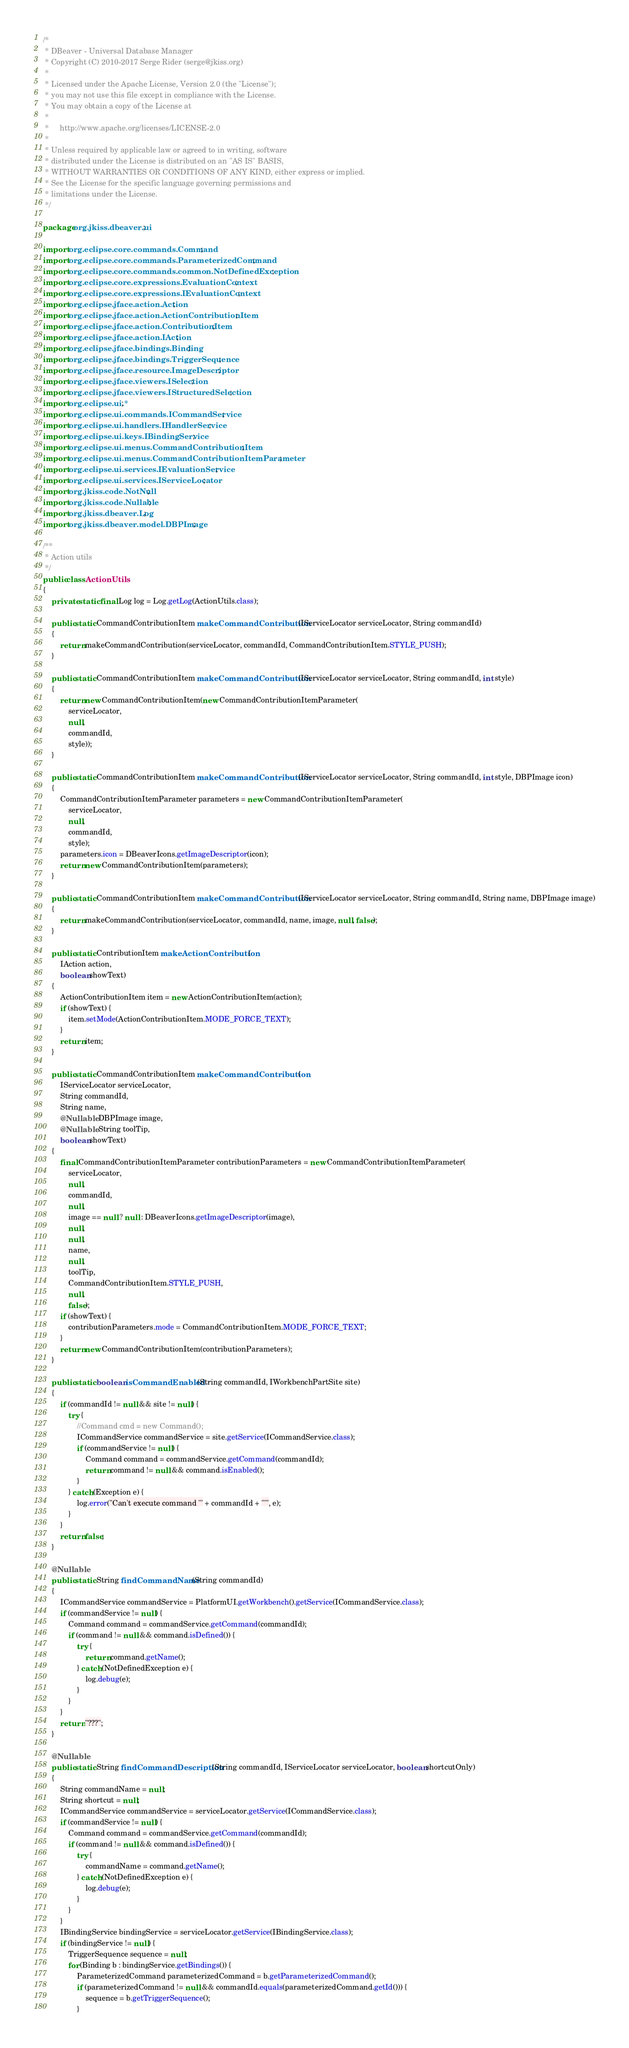<code> <loc_0><loc_0><loc_500><loc_500><_Java_>/*
 * DBeaver - Universal Database Manager
 * Copyright (C) 2010-2017 Serge Rider (serge@jkiss.org)
 *
 * Licensed under the Apache License, Version 2.0 (the "License");
 * you may not use this file except in compliance with the License.
 * You may obtain a copy of the License at
 *
 *     http://www.apache.org/licenses/LICENSE-2.0
 *
 * Unless required by applicable law or agreed to in writing, software
 * distributed under the License is distributed on an "AS IS" BASIS,
 * WITHOUT WARRANTIES OR CONDITIONS OF ANY KIND, either express or implied.
 * See the License for the specific language governing permissions and
 * limitations under the License.
 */

package org.jkiss.dbeaver.ui;

import org.eclipse.core.commands.Command;
import org.eclipse.core.commands.ParameterizedCommand;
import org.eclipse.core.commands.common.NotDefinedException;
import org.eclipse.core.expressions.EvaluationContext;
import org.eclipse.core.expressions.IEvaluationContext;
import org.eclipse.jface.action.Action;
import org.eclipse.jface.action.ActionContributionItem;
import org.eclipse.jface.action.ContributionItem;
import org.eclipse.jface.action.IAction;
import org.eclipse.jface.bindings.Binding;
import org.eclipse.jface.bindings.TriggerSequence;
import org.eclipse.jface.resource.ImageDescriptor;
import org.eclipse.jface.viewers.ISelection;
import org.eclipse.jface.viewers.IStructuredSelection;
import org.eclipse.ui.*;
import org.eclipse.ui.commands.ICommandService;
import org.eclipse.ui.handlers.IHandlerService;
import org.eclipse.ui.keys.IBindingService;
import org.eclipse.ui.menus.CommandContributionItem;
import org.eclipse.ui.menus.CommandContributionItemParameter;
import org.eclipse.ui.services.IEvaluationService;
import org.eclipse.ui.services.IServiceLocator;
import org.jkiss.code.NotNull;
import org.jkiss.code.Nullable;
import org.jkiss.dbeaver.Log;
import org.jkiss.dbeaver.model.DBPImage;

/**
 * Action utils
 */
public class ActionUtils
{
    private static final Log log = Log.getLog(ActionUtils.class);

    public static CommandContributionItem makeCommandContribution(IServiceLocator serviceLocator, String commandId)
    {
        return makeCommandContribution(serviceLocator, commandId, CommandContributionItem.STYLE_PUSH);
    }

    public static CommandContributionItem makeCommandContribution(IServiceLocator serviceLocator, String commandId, int style)
    {
        return new CommandContributionItem(new CommandContributionItemParameter(
            serviceLocator,
            null,
            commandId,
            style));
    }

    public static CommandContributionItem makeCommandContribution(IServiceLocator serviceLocator, String commandId, int style, DBPImage icon)
    {
        CommandContributionItemParameter parameters = new CommandContributionItemParameter(
            serviceLocator,
            null,
            commandId,
            style);
        parameters.icon = DBeaverIcons.getImageDescriptor(icon);
        return new CommandContributionItem(parameters);
    }

    public static CommandContributionItem makeCommandContribution(IServiceLocator serviceLocator, String commandId, String name, DBPImage image)
    {
        return makeCommandContribution(serviceLocator, commandId, name, image, null, false);
    }

    public static ContributionItem makeActionContribution(
        IAction action,
        boolean showText)
    {
        ActionContributionItem item = new ActionContributionItem(action);
        if (showText) {
            item.setMode(ActionContributionItem.MODE_FORCE_TEXT);
        }
        return item;
    }

    public static CommandContributionItem makeCommandContribution(
        IServiceLocator serviceLocator,
        String commandId,
        String name,
        @Nullable DBPImage image,
        @Nullable String toolTip,
        boolean showText)
    {
        final CommandContributionItemParameter contributionParameters = new CommandContributionItemParameter(
            serviceLocator,
            null,
            commandId,
            null,
            image == null ? null : DBeaverIcons.getImageDescriptor(image),
            null,
            null,
            name,
            null,
            toolTip,
            CommandContributionItem.STYLE_PUSH,
            null,
            false);
        if (showText) {
            contributionParameters.mode = CommandContributionItem.MODE_FORCE_TEXT;
        }
        return new CommandContributionItem(contributionParameters);
    }

    public static boolean isCommandEnabled(String commandId, IWorkbenchPartSite site)
    {
        if (commandId != null && site != null) {
            try {
                //Command cmd = new Command();
                ICommandService commandService = site.getService(ICommandService.class);
                if (commandService != null) {
                    Command command = commandService.getCommand(commandId);
                    return command != null && command.isEnabled();
                }
            } catch (Exception e) {
                log.error("Can't execute command '" + commandId + "'", e);
            }
        }
        return false;
    }

    @Nullable
    public static String findCommandName(String commandId)
    {
        ICommandService commandService = PlatformUI.getWorkbench().getService(ICommandService.class);
        if (commandService != null) {
            Command command = commandService.getCommand(commandId);
            if (command != null && command.isDefined()) {
                try {
                    return command.getName();
                } catch (NotDefinedException e) {
                    log.debug(e);
                }
            }
        }
        return "???";
    }

    @Nullable
    public static String findCommandDescription(String commandId, IServiceLocator serviceLocator, boolean shortcutOnly)
    {
        String commandName = null;
        String shortcut = null;
        ICommandService commandService = serviceLocator.getService(ICommandService.class);
        if (commandService != null) {
            Command command = commandService.getCommand(commandId);
            if (command != null && command.isDefined()) {
                try {
                    commandName = command.getName();
                } catch (NotDefinedException e) {
                    log.debug(e);
                }
            }
        }
        IBindingService bindingService = serviceLocator.getService(IBindingService.class);
        if (bindingService != null) {
            TriggerSequence sequence = null;
            for (Binding b : bindingService.getBindings()) {
                ParameterizedCommand parameterizedCommand = b.getParameterizedCommand();
                if (parameterizedCommand != null && commandId.equals(parameterizedCommand.getId())) {
                    sequence = b.getTriggerSequence();
                }</code> 